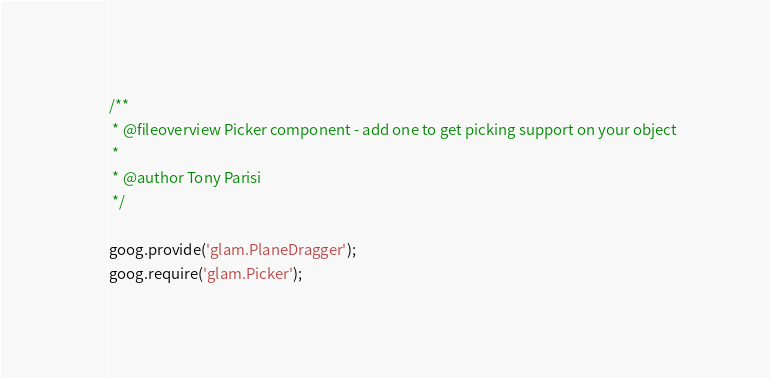<code> <loc_0><loc_0><loc_500><loc_500><_JavaScript_>/**
 * @fileoverview Picker component - add one to get picking support on your object
 * 
 * @author Tony Parisi
 */

goog.provide('glam.PlaneDragger');
goog.require('glam.Picker');
</code> 